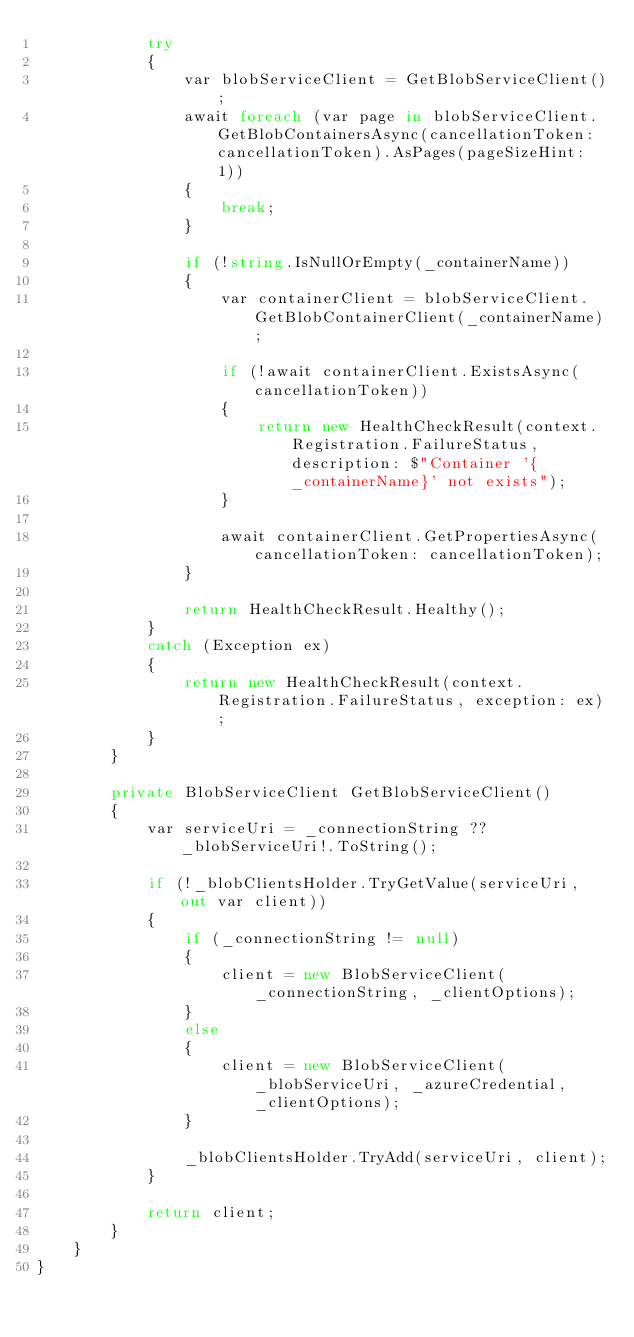<code> <loc_0><loc_0><loc_500><loc_500><_C#_>            try
            {
                var blobServiceClient = GetBlobServiceClient();
                await foreach (var page in blobServiceClient.GetBlobContainersAsync(cancellationToken: cancellationToken).AsPages(pageSizeHint: 1))
                {
                    break;
                }

                if (!string.IsNullOrEmpty(_containerName))
                {
                    var containerClient = blobServiceClient.GetBlobContainerClient(_containerName);

                    if (!await containerClient.ExistsAsync(cancellationToken))
                    {
                        return new HealthCheckResult(context.Registration.FailureStatus, description: $"Container '{_containerName}' not exists");
                    }

                    await containerClient.GetPropertiesAsync(cancellationToken: cancellationToken);
                }

                return HealthCheckResult.Healthy();
            }
            catch (Exception ex)
            {
                return new HealthCheckResult(context.Registration.FailureStatus, exception: ex);
            }
        }

        private BlobServiceClient GetBlobServiceClient()
        {
            var serviceUri = _connectionString ?? _blobServiceUri!.ToString();

            if (!_blobClientsHolder.TryGetValue(serviceUri, out var client))
            {
                if (_connectionString != null)
                {
                    client = new BlobServiceClient(_connectionString, _clientOptions);
                }
                else
                {
                    client = new BlobServiceClient(_blobServiceUri, _azureCredential, _clientOptions);
                }

                _blobClientsHolder.TryAdd(serviceUri, client);
            }

            return client;
        }
    }
}
</code> 